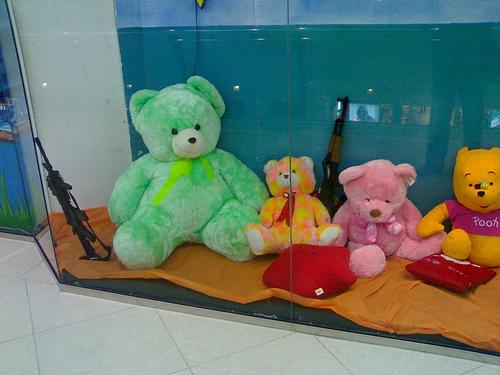Is this a game of some sort?
Give a very brief answer. No. What is the larger green bear dressed as?
Write a very short answer. Bear. What cartoon character is the bear on the right?
Concise answer only. Winnie pooh. How many polar bears are there?
Keep it brief. 0. How many bears are there?
Short answer required. 4. Is the green bear holding a gun?
Concise answer only. No. How many pillows are there?
Be succinct. 2. 